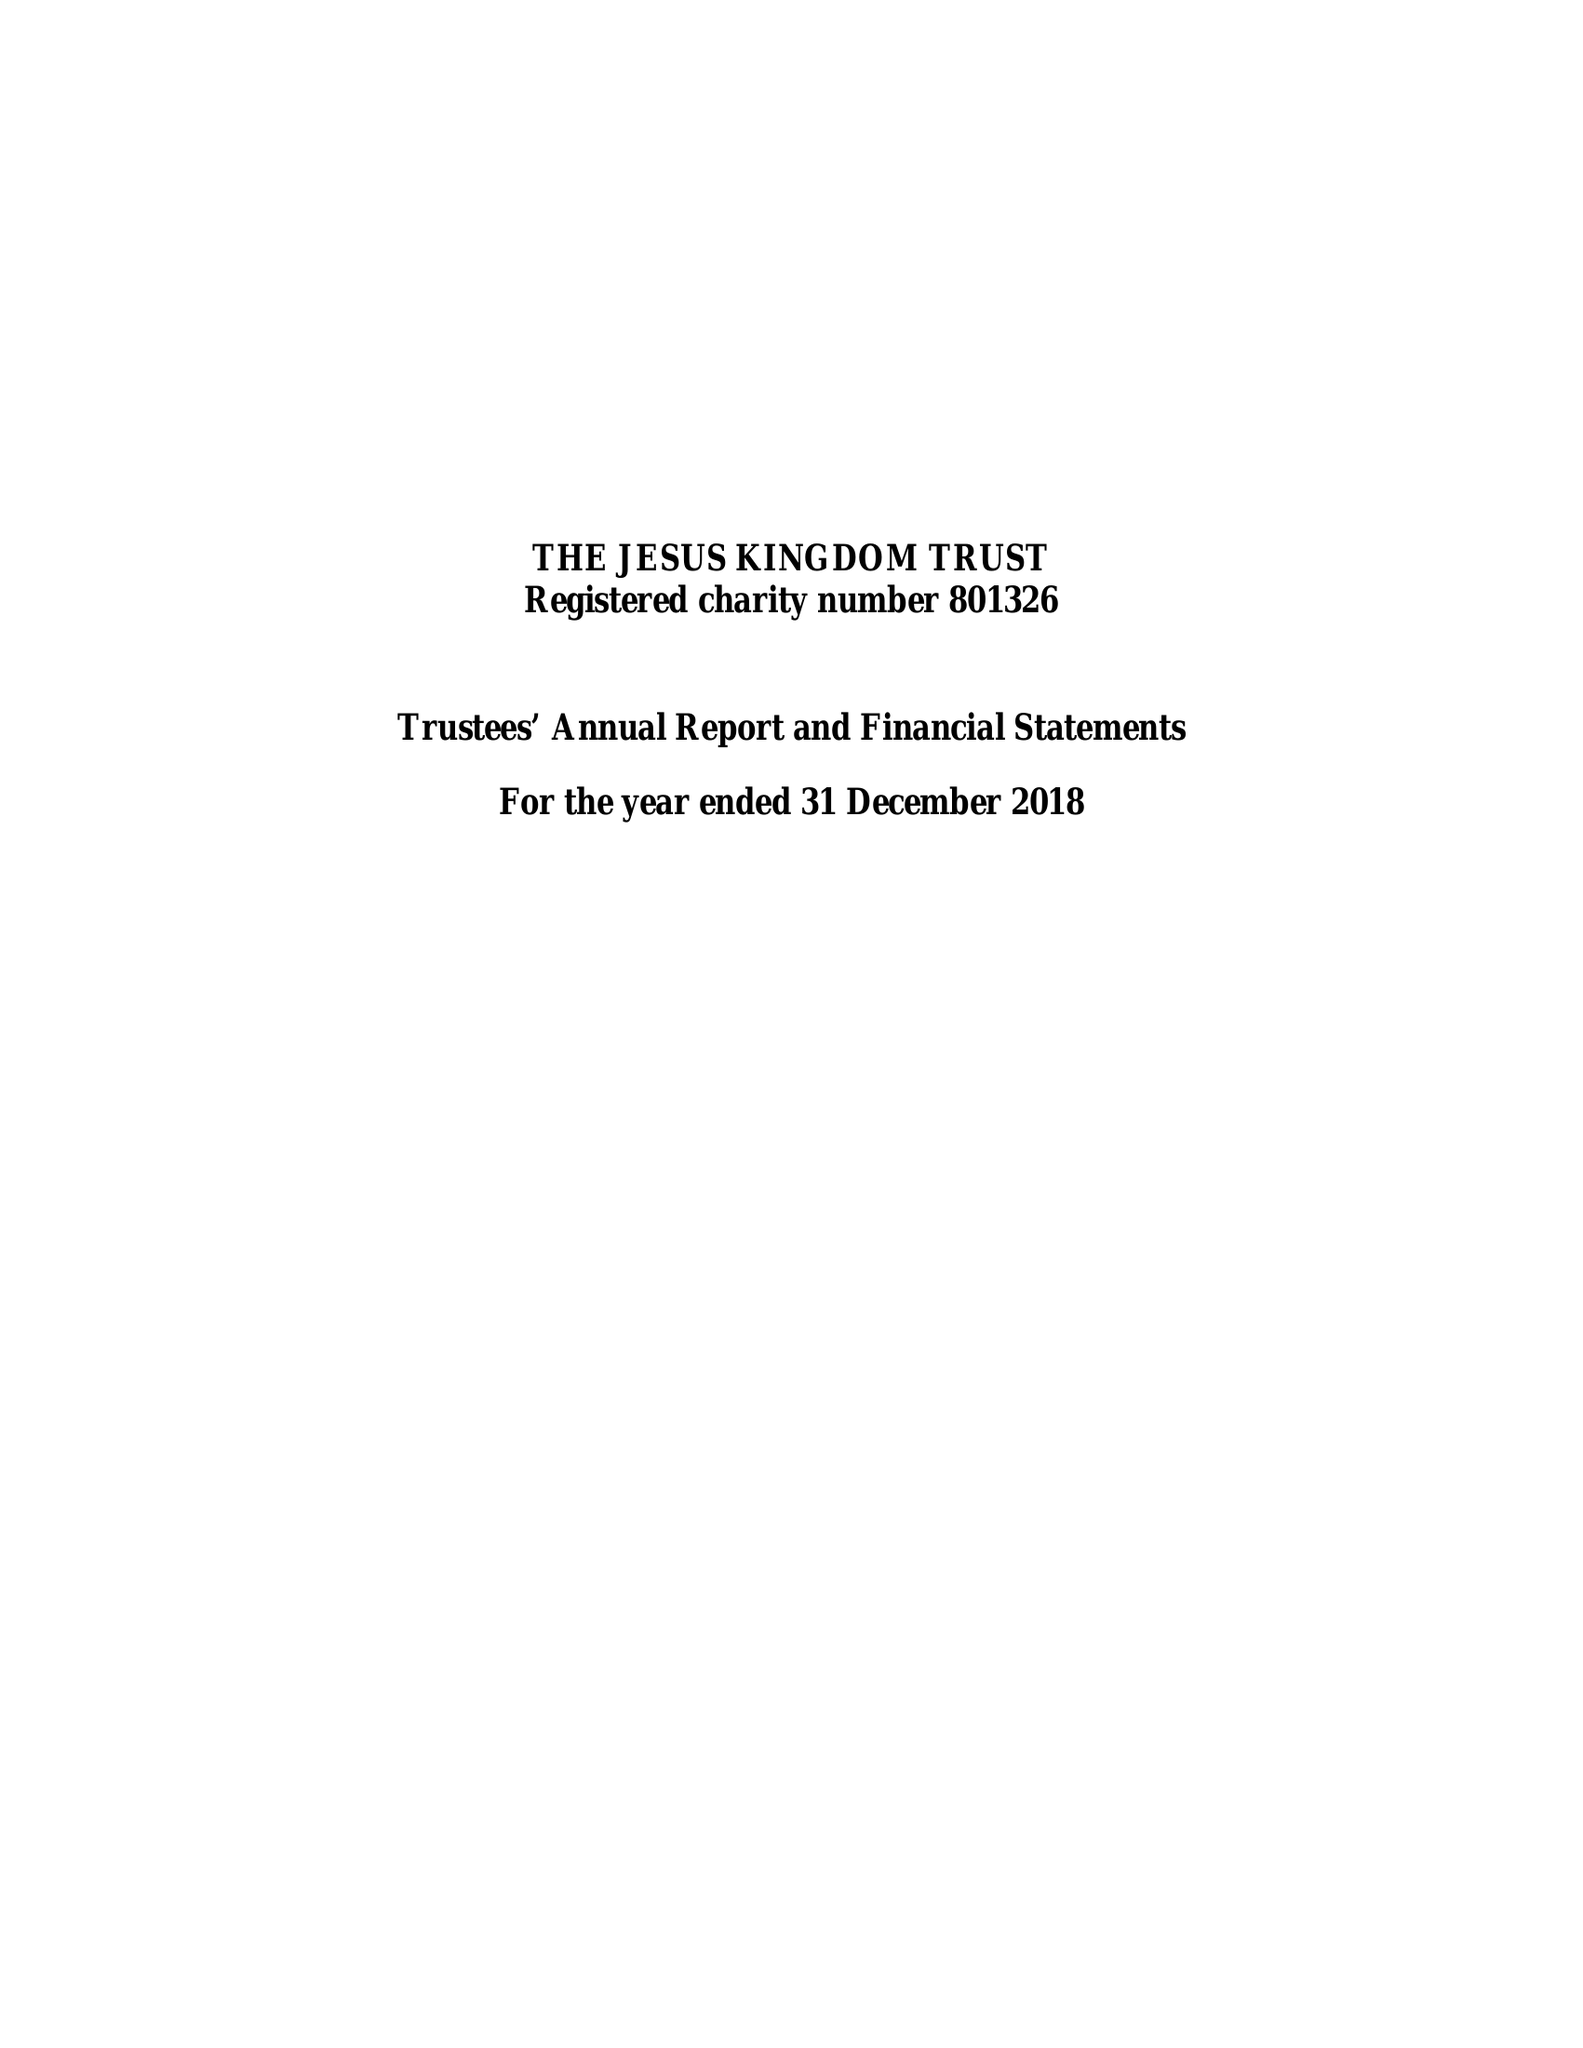What is the value for the spending_annually_in_british_pounds?
Answer the question using a single word or phrase. 478790.00 